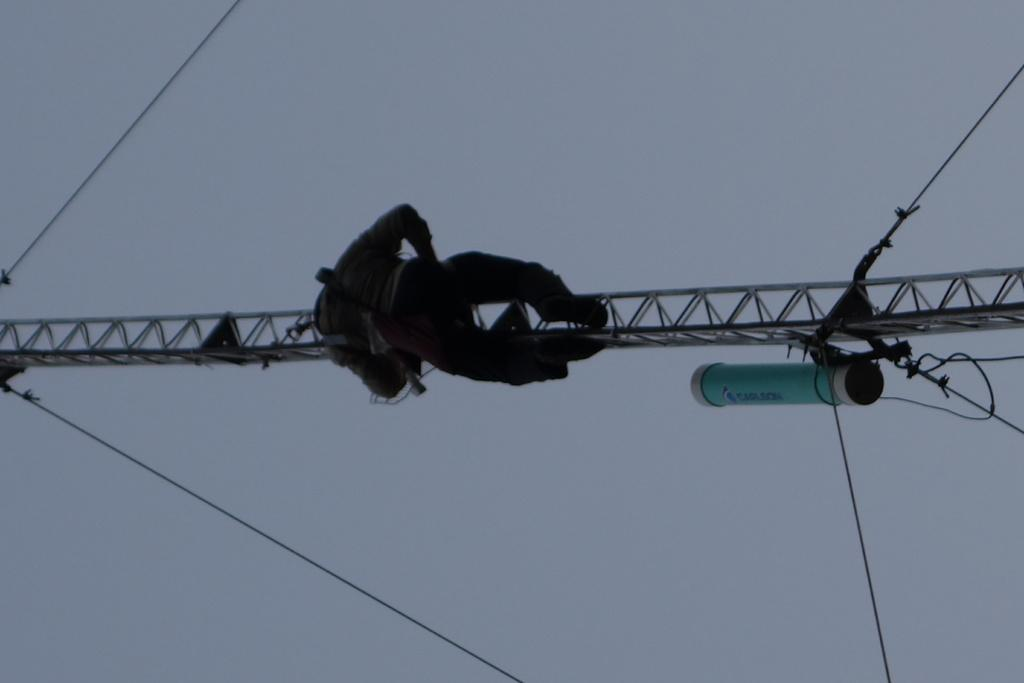What is the man in the image doing? The man is hanging from a metal rod in the image. What objects are visible that might be related to the man's activity? There are ropes visible in the image. What can be seen in the background of the image? There is a sky visible in the background of the image. What type of cap is the man's mother wearing in the image? There is no mention of a cap or the man's mother in the image, so we cannot answer this question. 